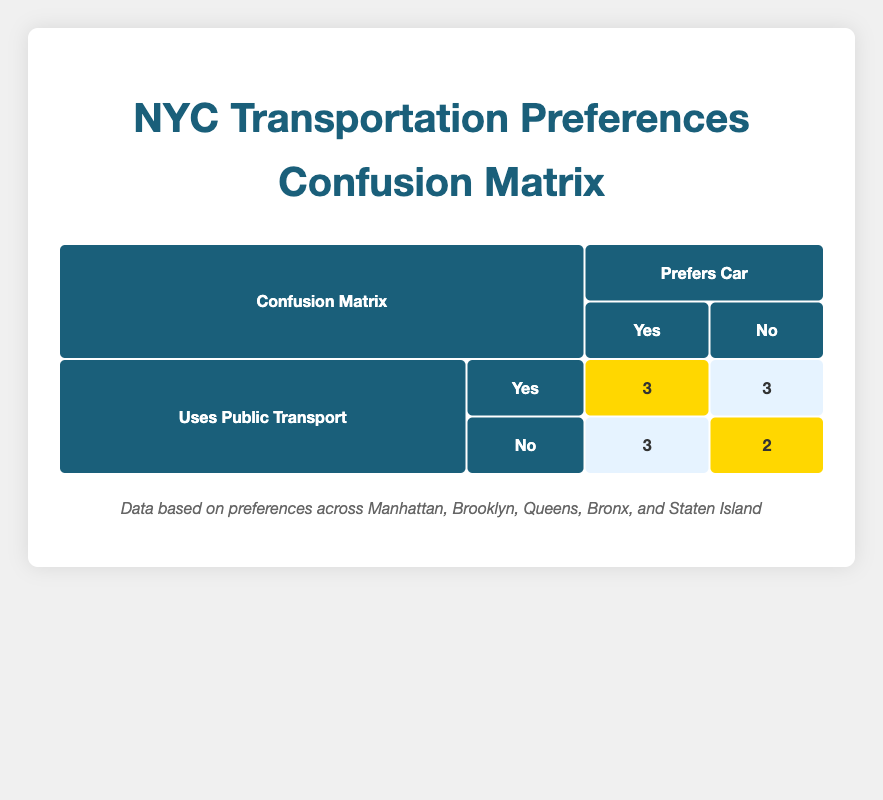What is the total number of people who prefer cars and also use public transport? The table indicates that 3 people prefer cars and use public transport, corresponding to the highlighted cell under "Prefers Car: Yes" and "Uses Public Transport: Yes."
Answer: 3 How many people use public transport and do not prefer cars? From the table, there are 3 people who use public transport and do not prefer cars according to the "No" column under "Prefers Car."
Answer: 3 What is the total number of people who prefer cars in the dataset? To find the total number of people who prefer cars, we add the values for "Prefers Car: Yes" across both "Uses Public Transport: Yes" and "No" categories. That results in 3 (Yes, Yes) + 3 (No, No) + 3 (Yes, No) = 9.
Answer: 9 In how many neighborhoods do people not use public transport and prefer cars? The neighborhoods where people do not use public transport but prefer cars are Queens, Staten Island, and Manhattan, totaling 3 instances as indicated in the corresponding cells.
Answer: 3 Are there more people who prefer cars and use public transport or those who prefer cars and do not use public transport? The table shows that 3 prefer cars and use public transport, while 3 prefer cars but do not use public transport. They are equal in number.
Answer: They are equal 